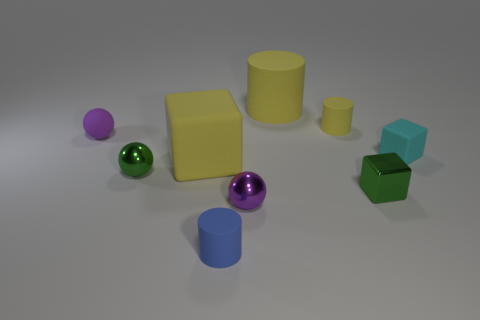What number of other objects are the same material as the green ball?
Ensure brevity in your answer.  2. What shape is the cyan thing that is behind the big matte cube?
Provide a short and direct response. Cube. What material is the block to the left of the big yellow matte object that is behind the large yellow cube made of?
Your response must be concise. Rubber. Are there more purple spheres that are behind the tiny purple metal thing than large gray metal cylinders?
Make the answer very short. Yes. What number of other things are the same color as the big block?
Your response must be concise. 2. What shape is the purple shiny object that is the same size as the matte sphere?
Your answer should be very brief. Sphere. There is a tiny matte cylinder that is on the left side of the small purple thing in front of the tiny cyan matte block; what number of purple balls are to the left of it?
Provide a succinct answer. 1. How many metal objects are large blue spheres or small purple spheres?
Offer a very short reply. 1. The rubber cylinder that is behind the big block and left of the small yellow rubber thing is what color?
Provide a short and direct response. Yellow. Is the size of the yellow rubber block behind the blue cylinder the same as the green metallic block?
Give a very brief answer. No. 